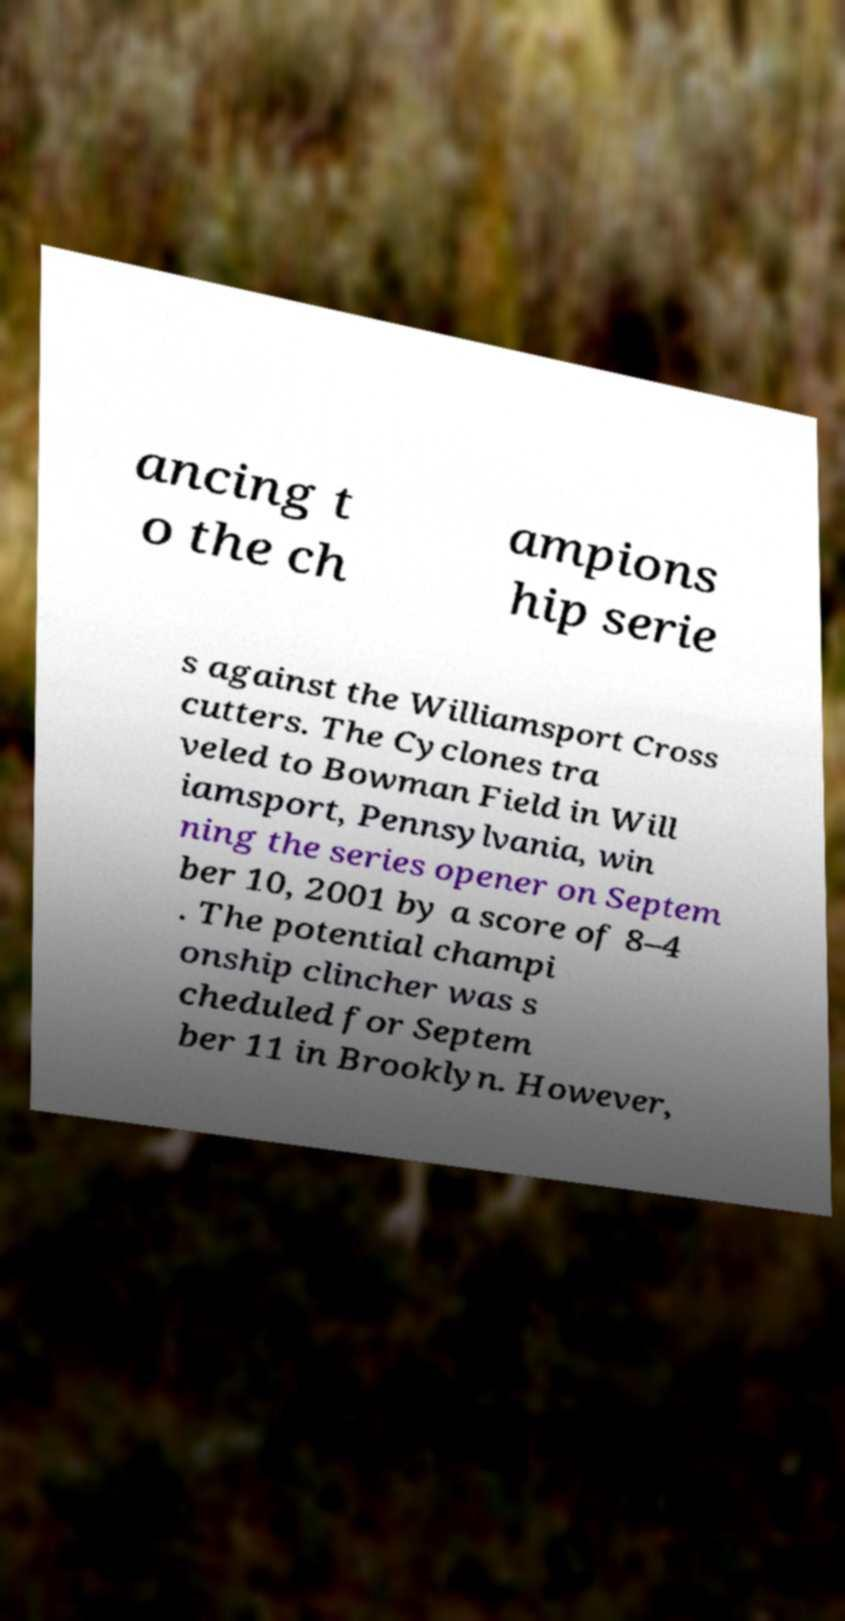There's text embedded in this image that I need extracted. Can you transcribe it verbatim? ancing t o the ch ampions hip serie s against the Williamsport Cross cutters. The Cyclones tra veled to Bowman Field in Will iamsport, Pennsylvania, win ning the series opener on Septem ber 10, 2001 by a score of 8–4 . The potential champi onship clincher was s cheduled for Septem ber 11 in Brooklyn. However, 